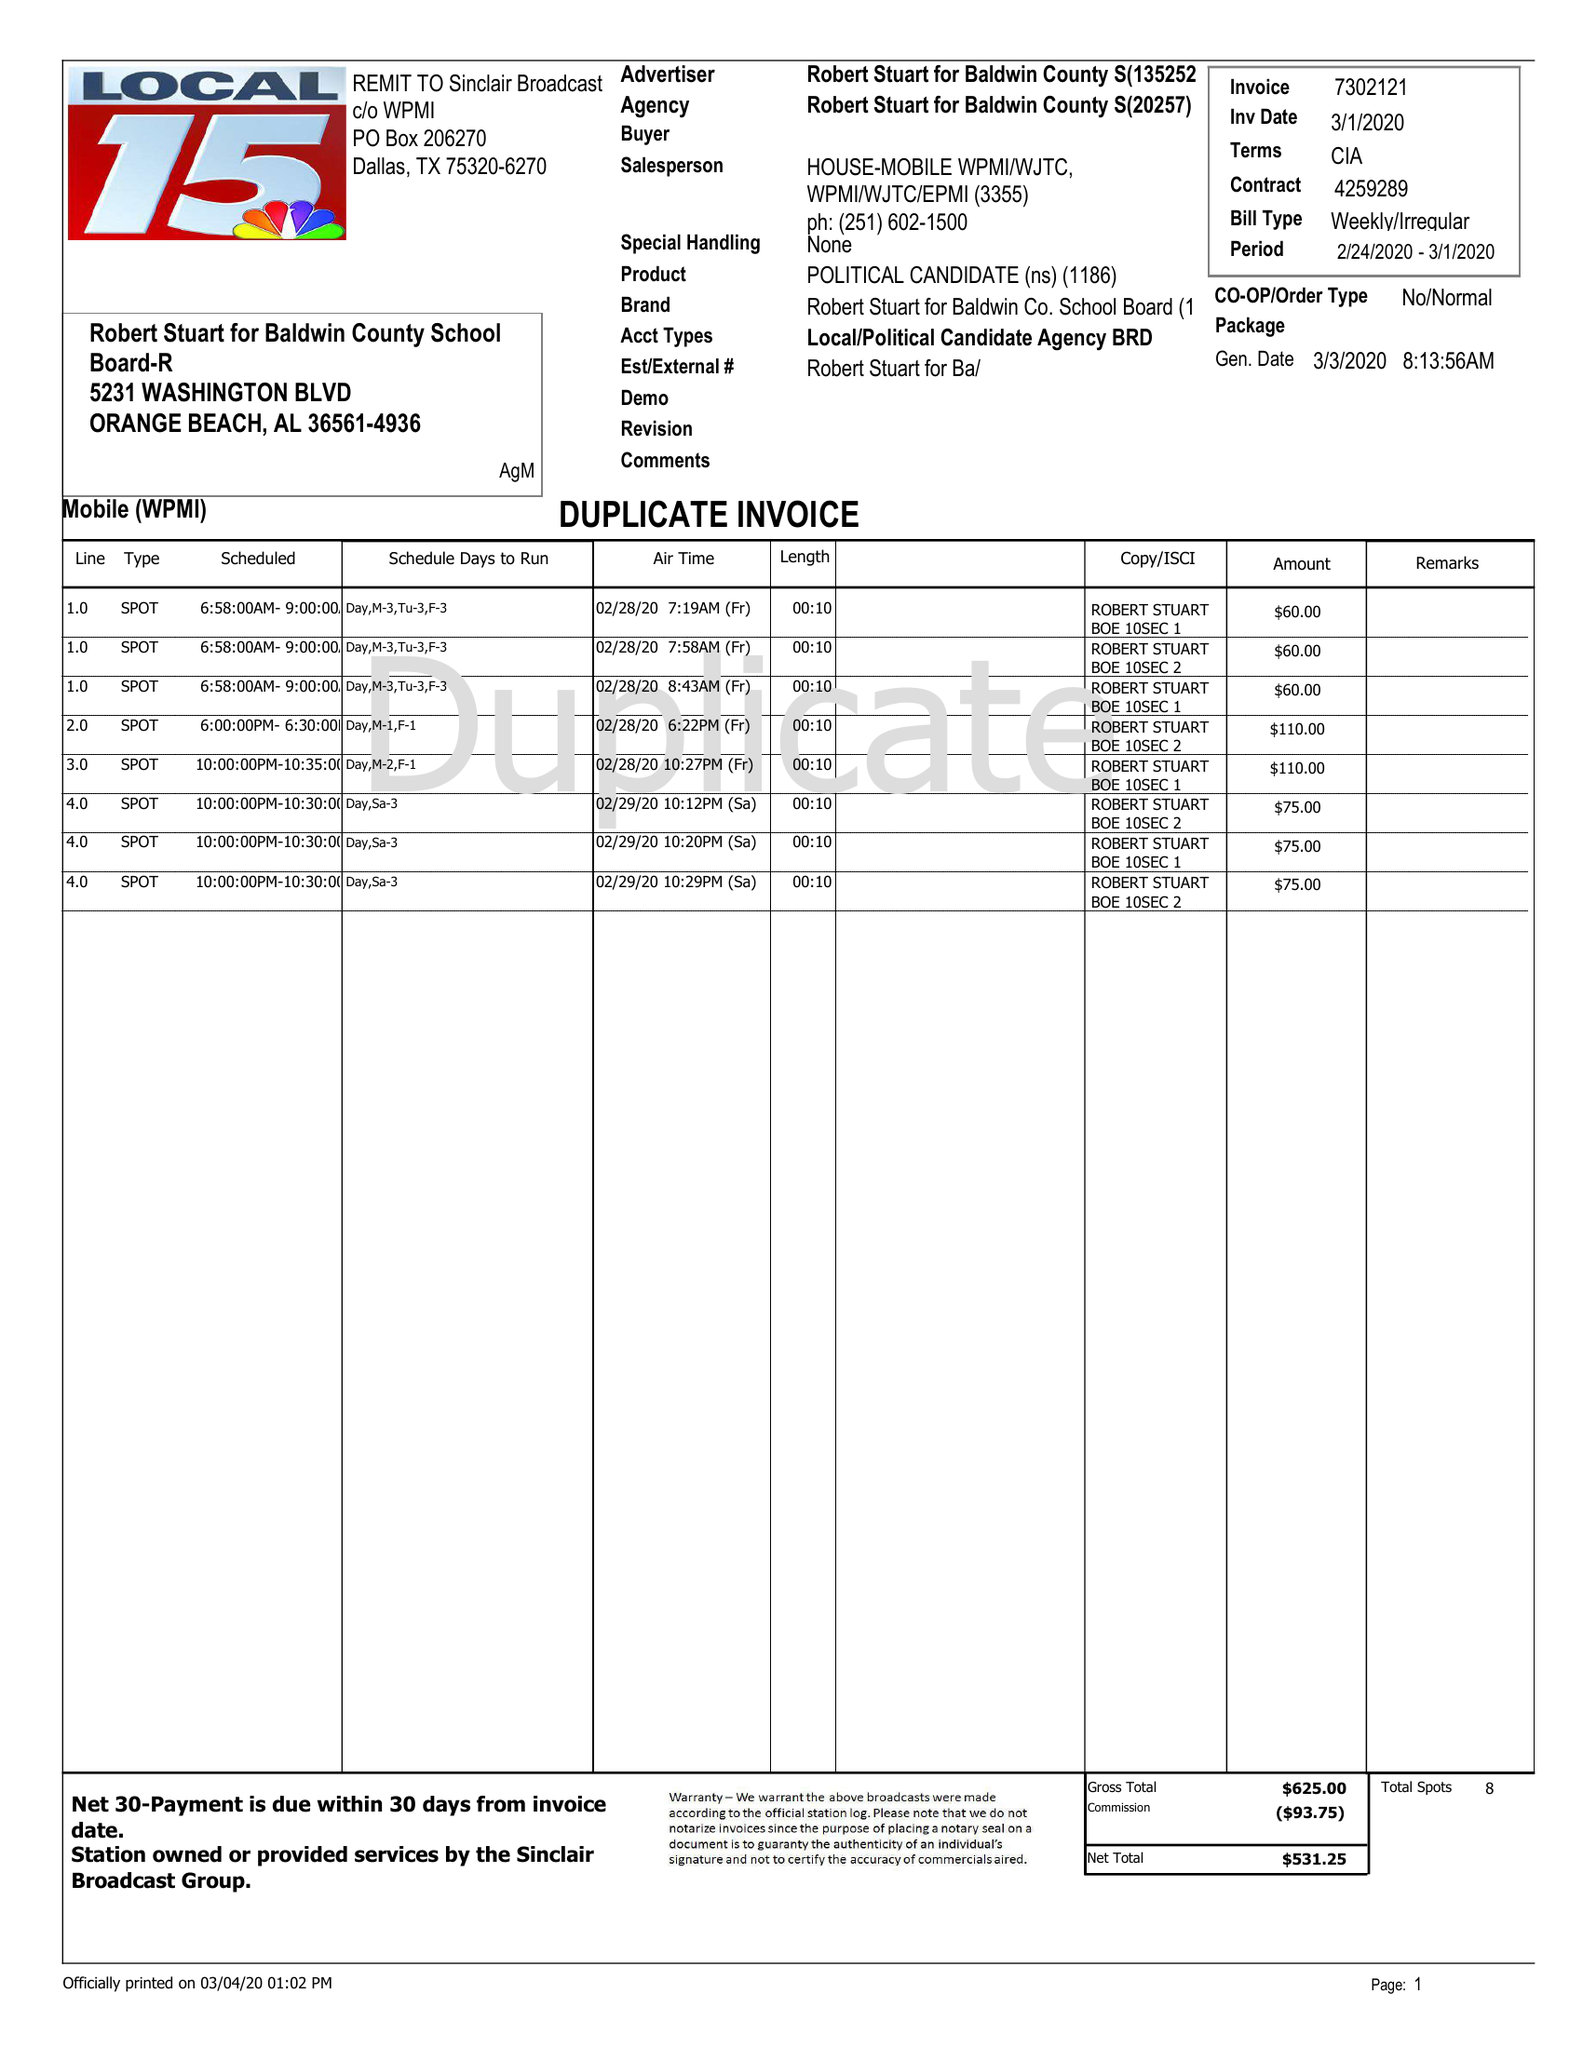What is the value for the contract_num?
Answer the question using a single word or phrase. 4259289 